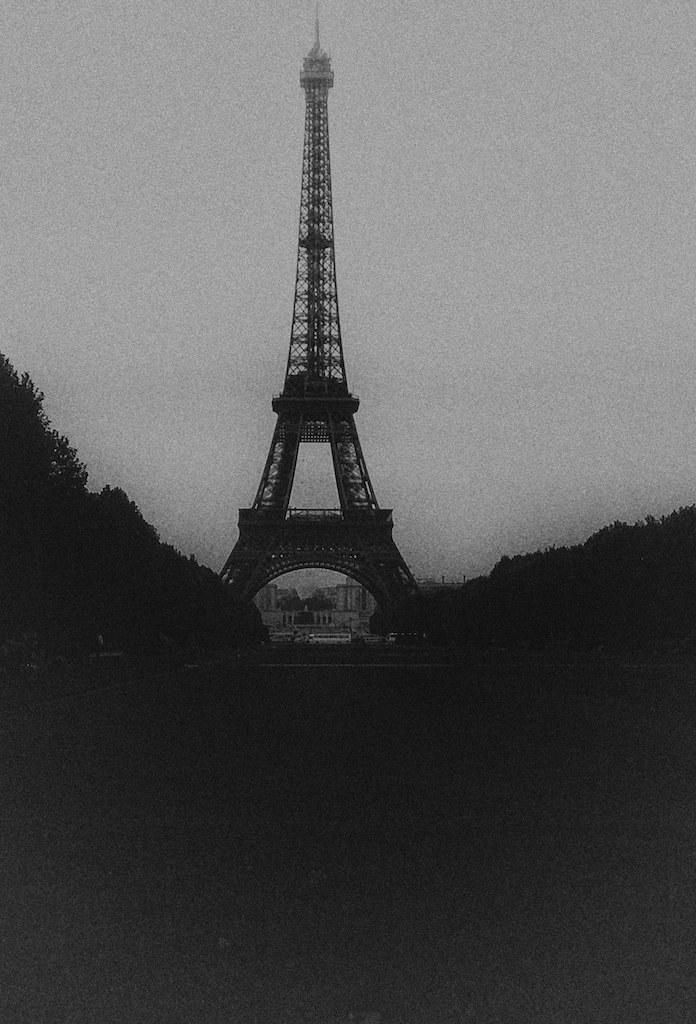What is the color scheme of the image? The image is black and white. What is the main subject in the middle of the image? There is a tower in the middle of the image. What type of pen is being used to draw the tower in the image? There is no pen or drawing activity present in the image; it is a photograph or illustration of a tower. Can you hear the tower talking in the image? The tower is an inanimate object and cannot talk, so it is not possible to hear it talking in the image. 